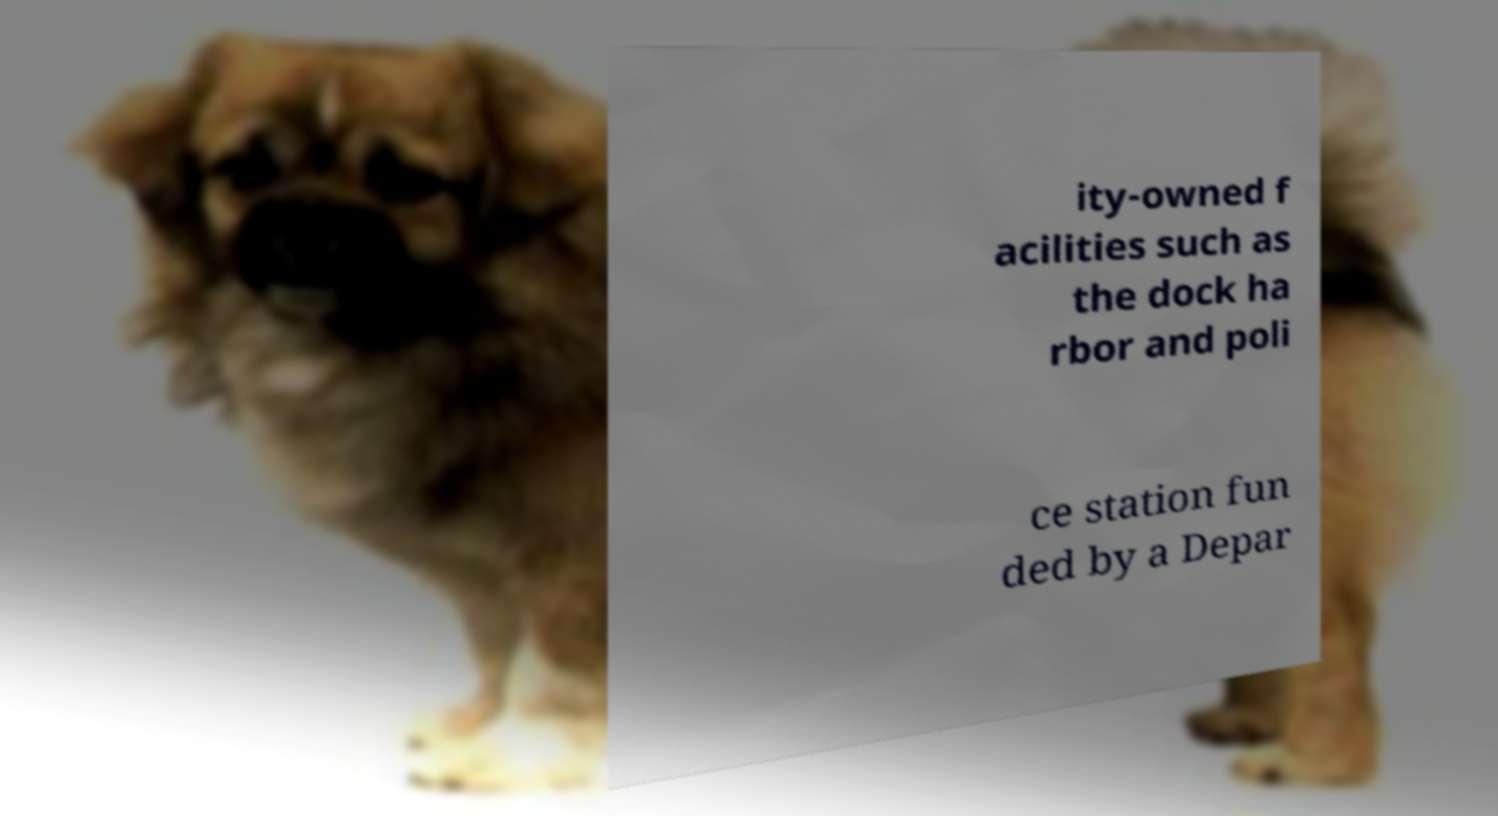Please read and relay the text visible in this image. What does it say? ity-owned f acilities such as the dock ha rbor and poli ce station fun ded by a Depar 